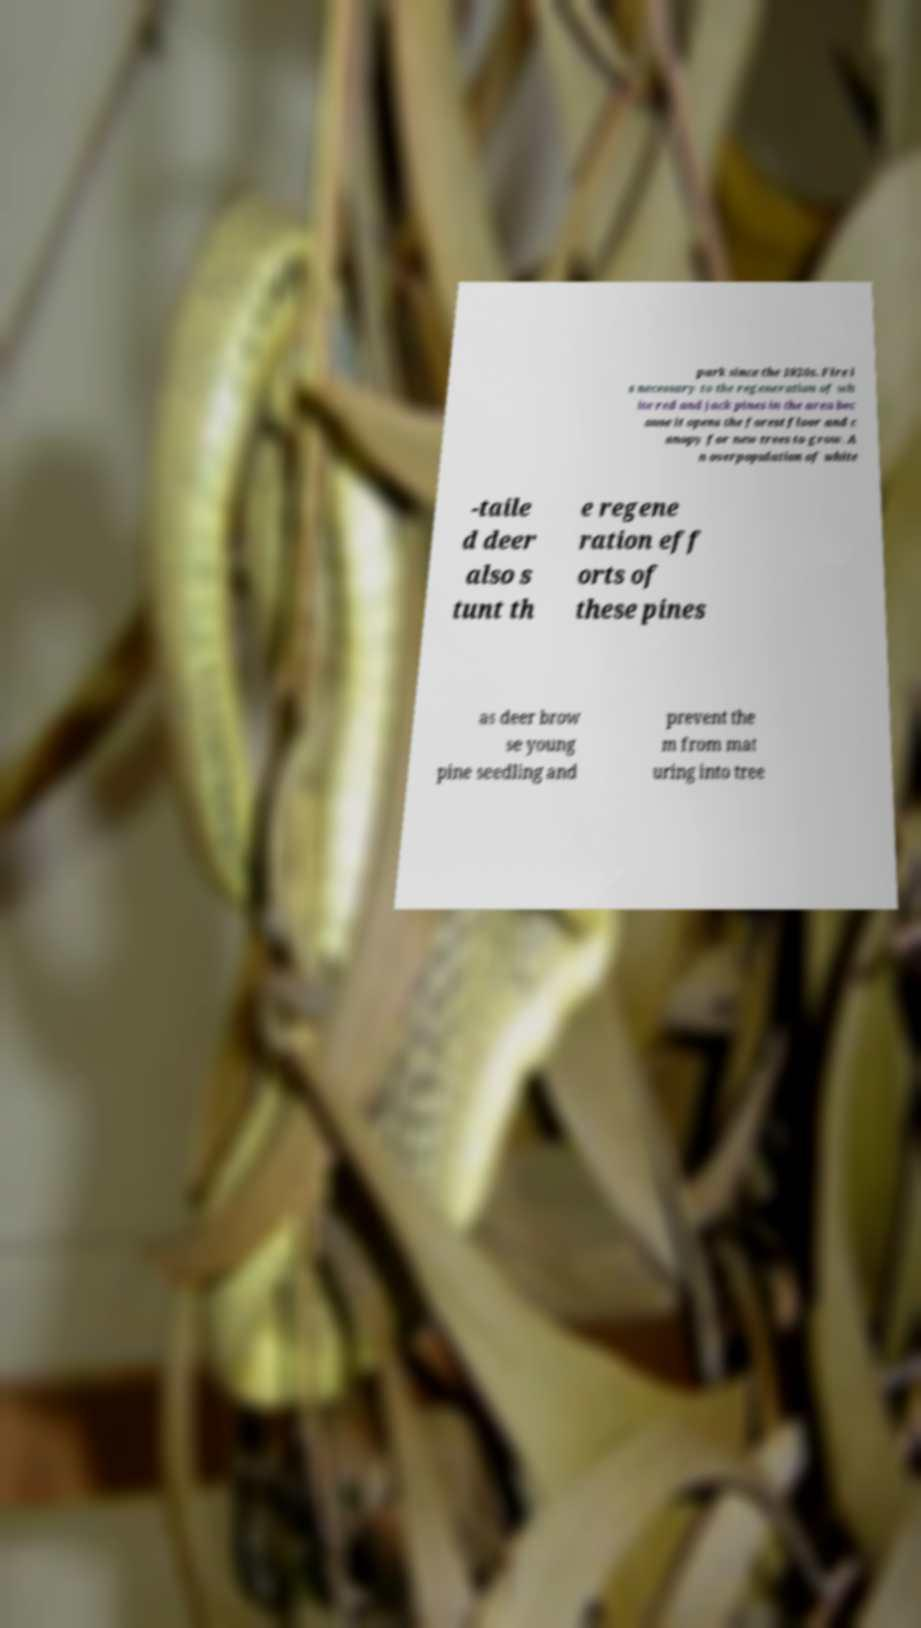There's text embedded in this image that I need extracted. Can you transcribe it verbatim? park since the 1920s. Fire i s necessary to the regeneration of wh ite red and jack pines in the area bec ause it opens the forest floor and c anopy for new trees to grow. A n overpopulation of white -taile d deer also s tunt th e regene ration eff orts of these pines as deer brow se young pine seedling and prevent the m from mat uring into tree 